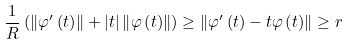<formula> <loc_0><loc_0><loc_500><loc_500>\frac { 1 } { R } \left ( \left \| \varphi ^ { \prime } \left ( t \right ) \right \| + \left | t \right | \left \| \varphi \left ( t \right ) \right \| \right ) \geq \left \| \varphi ^ { \prime } \left ( t \right ) - t \varphi \left ( t \right ) \right \| \geq r</formula> 